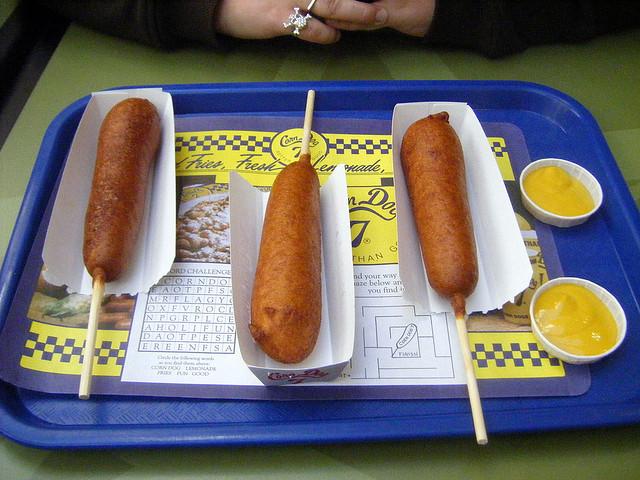What color is the tray?
Short answer required. Blue. How many corn dogs are facing the camera?
Quick response, please. 1. How many mustards are here?
Concise answer only. 2. 